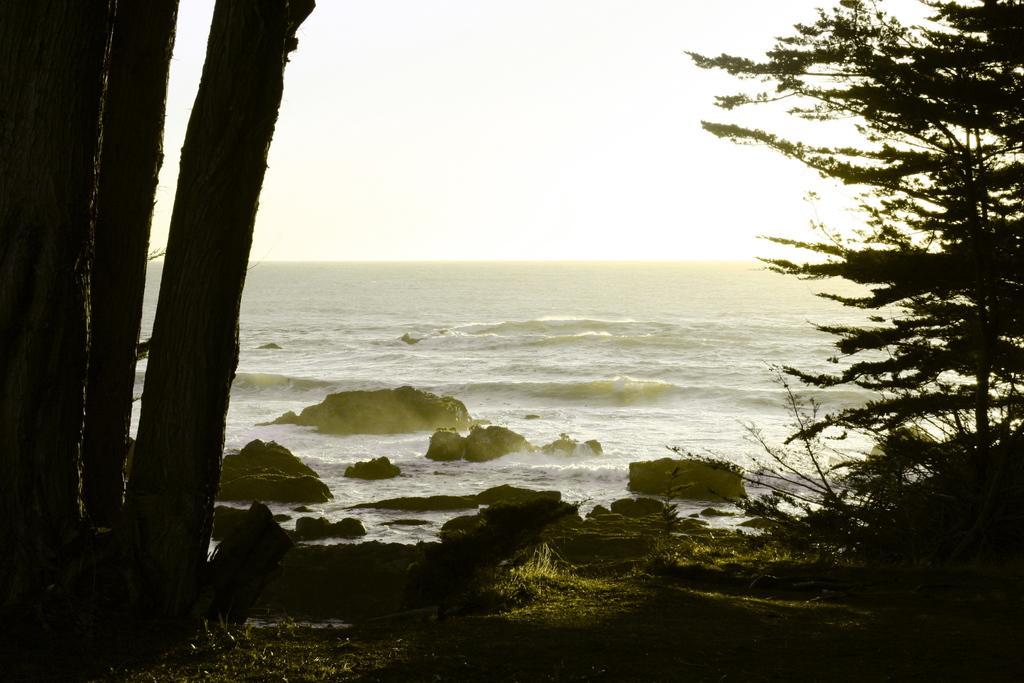Could you give a brief overview of what you see in this image? In this image in the front on the left side there are trees. On the right side there are plants and in the background there is an ocean. 